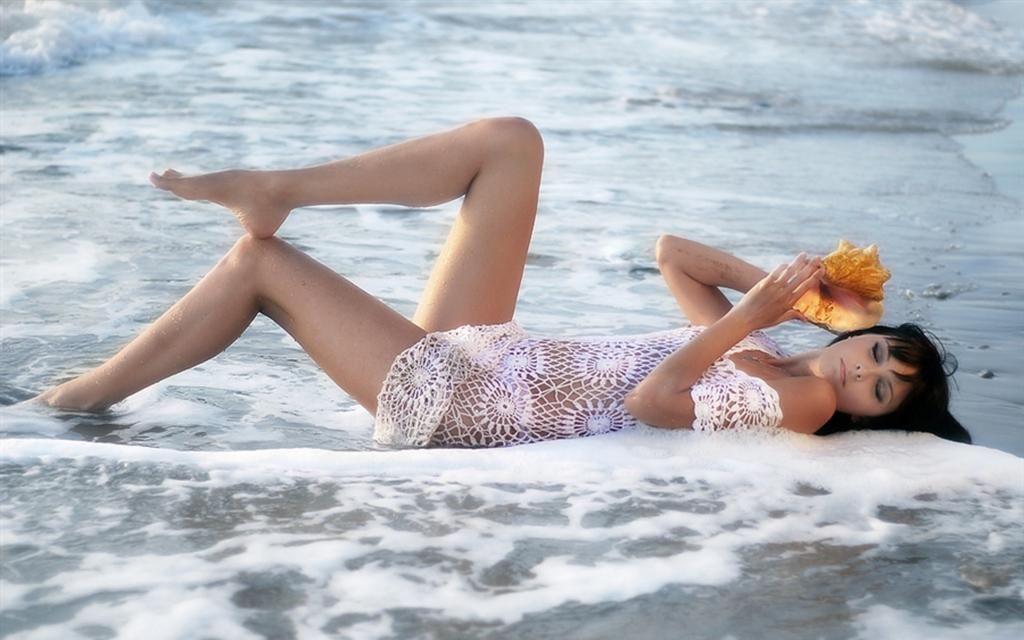What is the main subject of the image? There is a person lying in the center of the image. What is the person holding in the image? The person is holding an object. What can be seen at the bottom of the image? There is water visible at the bottom of the image, and foam is present in the water. What is visible in the background of the image? There is water visible in the background of the image. How does the person in the image express their surprise at the sudden heat wave? There is no indication of a heat wave or the person expressing surprise in the image. The image only shows a person lying down and holding an object, with water visible at the bottom and in the background. 